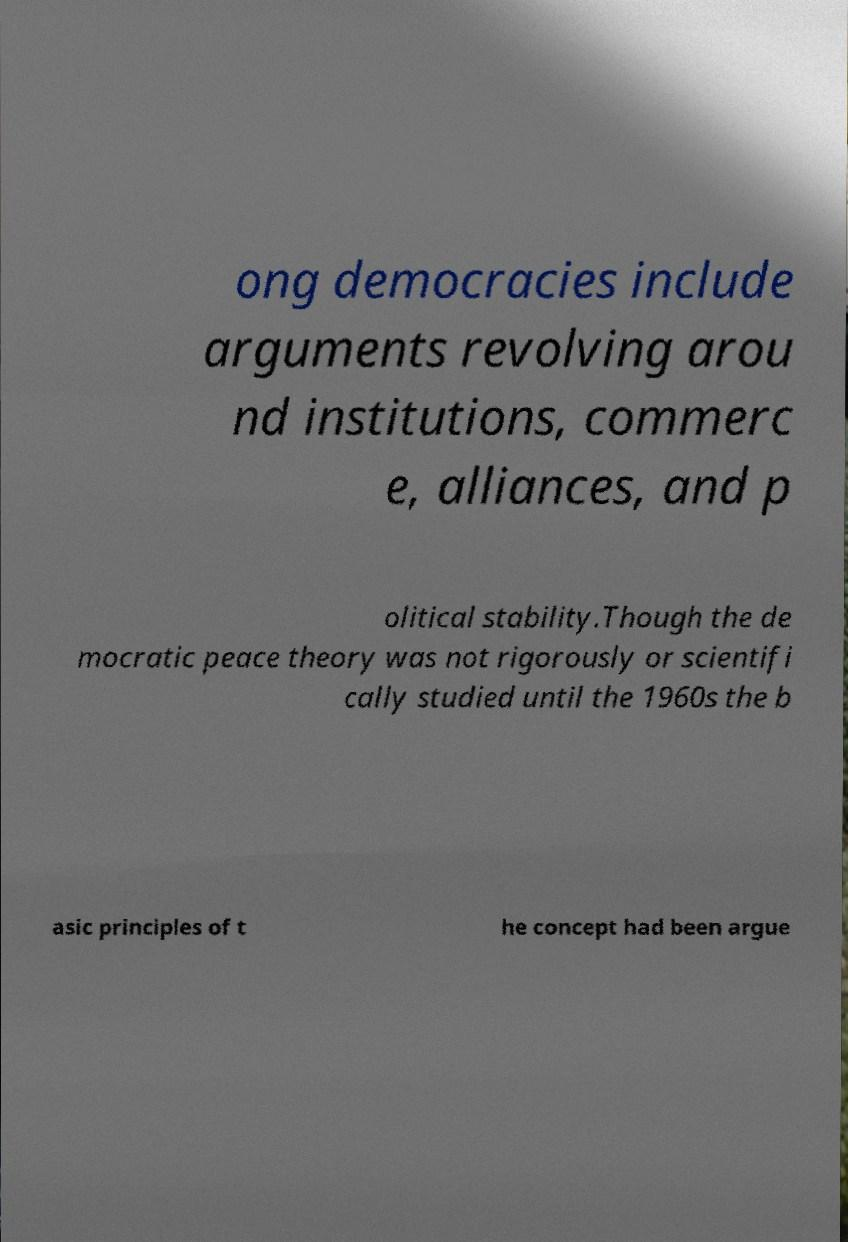Can you accurately transcribe the text from the provided image for me? ong democracies include arguments revolving arou nd institutions, commerc e, alliances, and p olitical stability.Though the de mocratic peace theory was not rigorously or scientifi cally studied until the 1960s the b asic principles of t he concept had been argue 